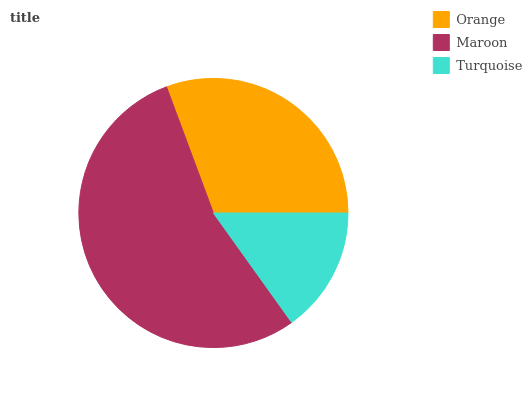Is Turquoise the minimum?
Answer yes or no. Yes. Is Maroon the maximum?
Answer yes or no. Yes. Is Maroon the minimum?
Answer yes or no. No. Is Turquoise the maximum?
Answer yes or no. No. Is Maroon greater than Turquoise?
Answer yes or no. Yes. Is Turquoise less than Maroon?
Answer yes or no. Yes. Is Turquoise greater than Maroon?
Answer yes or no. No. Is Maroon less than Turquoise?
Answer yes or no. No. Is Orange the high median?
Answer yes or no. Yes. Is Orange the low median?
Answer yes or no. Yes. Is Turquoise the high median?
Answer yes or no. No. Is Turquoise the low median?
Answer yes or no. No. 